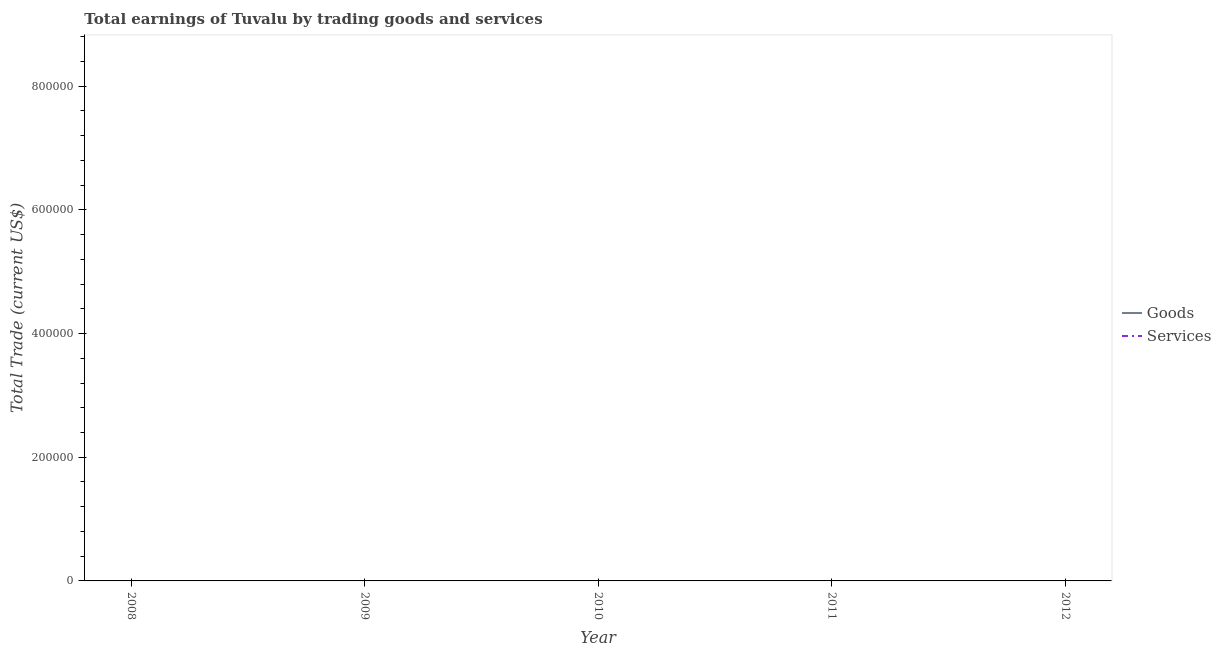How many different coloured lines are there?
Make the answer very short. 0. What is the total amount earned by trading goods in the graph?
Give a very brief answer. 0. What is the difference between the amount earned by trading services in 2009 and the amount earned by trading goods in 2011?
Your answer should be compact. 0. What is the average amount earned by trading goods per year?
Your response must be concise. 0. In how many years, is the amount earned by trading goods greater than 720000 US$?
Your answer should be compact. 0. Does the amount earned by trading services monotonically increase over the years?
Give a very brief answer. No. Is the amount earned by trading services strictly greater than the amount earned by trading goods over the years?
Your answer should be very brief. No. How many lines are there?
Your answer should be very brief. 0. How many years are there in the graph?
Your answer should be compact. 5. Are the values on the major ticks of Y-axis written in scientific E-notation?
Provide a short and direct response. No. Does the graph contain any zero values?
Your answer should be very brief. Yes. Does the graph contain grids?
Your response must be concise. No. What is the title of the graph?
Provide a succinct answer. Total earnings of Tuvalu by trading goods and services. Does "Number of arrivals" appear as one of the legend labels in the graph?
Provide a short and direct response. No. What is the label or title of the X-axis?
Offer a terse response. Year. What is the label or title of the Y-axis?
Offer a terse response. Total Trade (current US$). What is the Total Trade (current US$) in Services in 2008?
Offer a very short reply. 0. What is the Total Trade (current US$) of Goods in 2009?
Your response must be concise. 0. What is the Total Trade (current US$) in Services in 2009?
Make the answer very short. 0. What is the Total Trade (current US$) in Goods in 2010?
Offer a terse response. 0. What is the Total Trade (current US$) in Services in 2010?
Provide a succinct answer. 0. What is the Total Trade (current US$) in Goods in 2011?
Provide a succinct answer. 0. What is the Total Trade (current US$) of Services in 2011?
Your response must be concise. 0. What is the Total Trade (current US$) in Goods in 2012?
Provide a short and direct response. 0. 